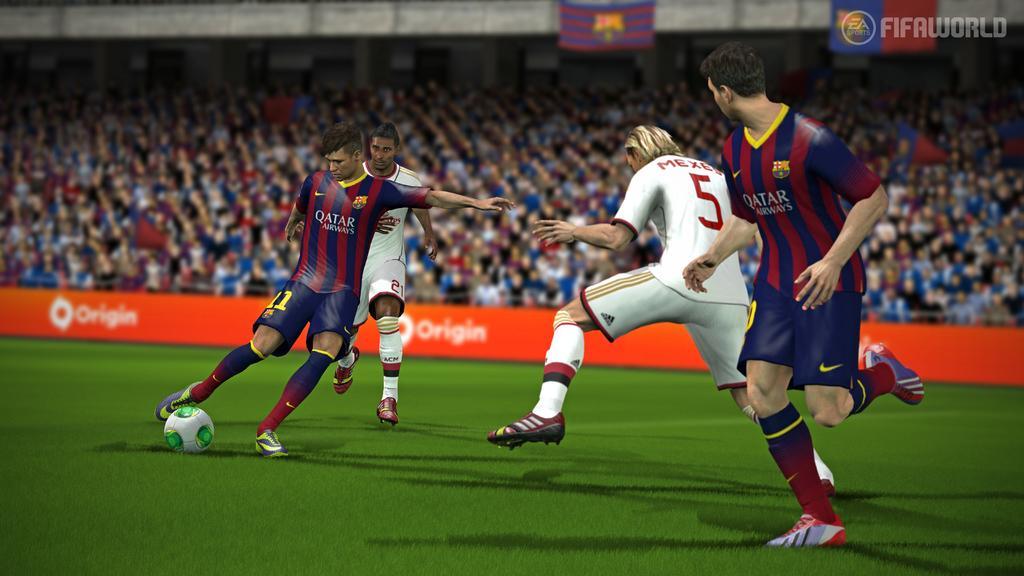How would you summarize this image in a sentence or two? This is a picture of a video game where a person is running by kicking a ball , another 3 persons are running in the ground , and in back ground there are group of people. 